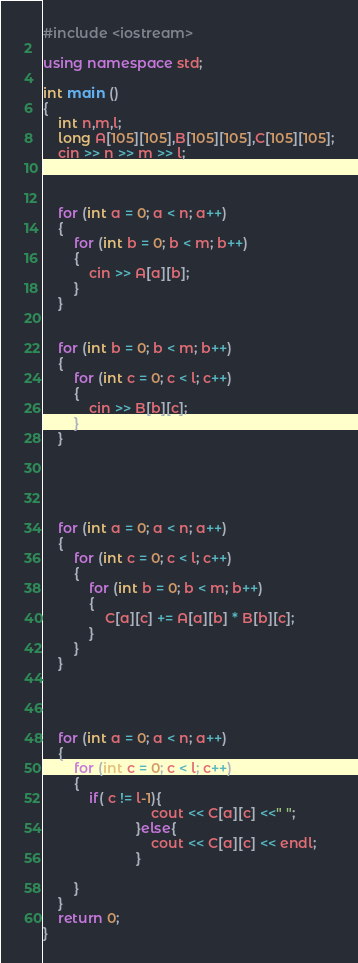Convert code to text. <code><loc_0><loc_0><loc_500><loc_500><_C++_>#include <iostream>

using namespace std;

int main ()
{
	int n,m,l;
	long A[105][105],B[105][105],C[105][105];
	cin >> n >> m >> l;



	for (int a = 0; a < n; a++)
	{
		for (int b = 0; b < m; b++)
		{
			cin >> A[a][b];
		}
	}


	for (int b = 0; b < m; b++)
	{
		for (int c = 0; c < l; c++)
		{
			cin >> B[b][c];
		}
	}





	for (int a = 0; a < n; a++)
	{
		for (int c = 0; c < l; c++)
		{
			for (int b = 0; b < m; b++)
			{
				C[a][c] += A[a][b] * B[b][c];
			}
		}
	}




	for (int a = 0; a < n; a++)
	{
		for (int c = 0; c < l; c++)
		{
			if( c != l-1){
			                cout << C[a][c] <<" ";
			            }else{
			                cout << C[a][c] << endl;
			            }

		}
	}
	return 0;
}</code> 